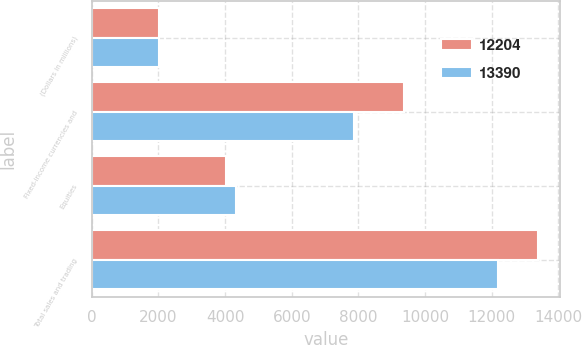Convert chart. <chart><loc_0><loc_0><loc_500><loc_500><stacked_bar_chart><ecel><fcel>(Dollars in millions)<fcel>Fixed-income currencies and<fcel>Equities<fcel>Total sales and trading<nl><fcel>12204<fcel>2016<fcel>9373<fcel>4017<fcel>13390<nl><fcel>13390<fcel>2015<fcel>7869<fcel>4335<fcel>12204<nl></chart> 